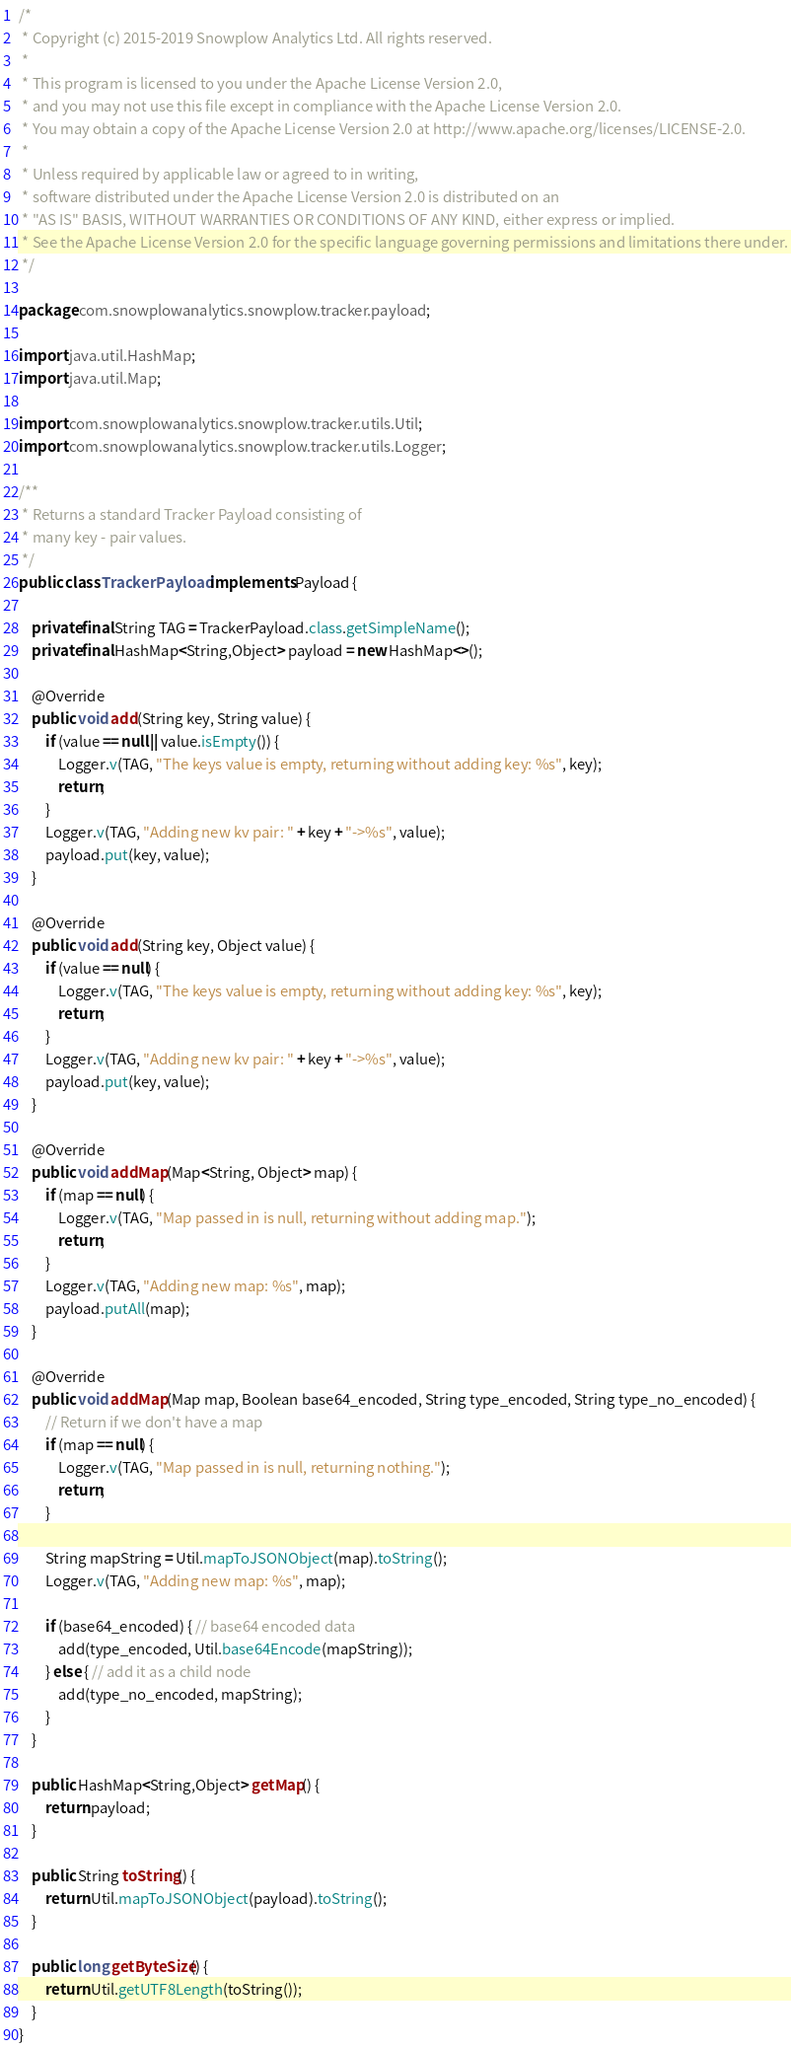<code> <loc_0><loc_0><loc_500><loc_500><_Java_>/*
 * Copyright (c) 2015-2019 Snowplow Analytics Ltd. All rights reserved.
 *
 * This program is licensed to you under the Apache License Version 2.0,
 * and you may not use this file except in compliance with the Apache License Version 2.0.
 * You may obtain a copy of the Apache License Version 2.0 at http://www.apache.org/licenses/LICENSE-2.0.
 *
 * Unless required by applicable law or agreed to in writing,
 * software distributed under the Apache License Version 2.0 is distributed on an
 * "AS IS" BASIS, WITHOUT WARRANTIES OR CONDITIONS OF ANY KIND, either express or implied.
 * See the Apache License Version 2.0 for the specific language governing permissions and limitations there under.
 */

package com.snowplowanalytics.snowplow.tracker.payload;

import java.util.HashMap;
import java.util.Map;

import com.snowplowanalytics.snowplow.tracker.utils.Util;
import com.snowplowanalytics.snowplow.tracker.utils.Logger;

/**
 * Returns a standard Tracker Payload consisting of
 * many key - pair values.
 */
public class TrackerPayload implements Payload {

    private final String TAG = TrackerPayload.class.getSimpleName();
    private final HashMap<String,Object> payload = new HashMap<>();
    
    @Override
    public void add(String key, String value) {
        if (value == null || value.isEmpty()) {
            Logger.v(TAG, "The keys value is empty, returning without adding key: %s", key);
            return;
        }
        Logger.v(TAG, "Adding new kv pair: " + key + "->%s", value);
        payload.put(key, value);
    }

    @Override
    public void add(String key, Object value) {
        if (value == null) {
            Logger.v(TAG, "The keys value is empty, returning without adding key: %s", key);
            return;
        }
        Logger.v(TAG, "Adding new kv pair: " + key + "->%s", value);
        payload.put(key, value);
    }

    @Override
    public void addMap(Map<String, Object> map) {
        if (map == null) {
            Logger.v(TAG, "Map passed in is null, returning without adding map.");
            return;
        }
        Logger.v(TAG, "Adding new map: %s", map);
        payload.putAll(map);
    }

    @Override
    public void addMap(Map map, Boolean base64_encoded, String type_encoded, String type_no_encoded) {
        // Return if we don't have a map
        if (map == null) {
            Logger.v(TAG, "Map passed in is null, returning nothing.");
            return;
        }

        String mapString = Util.mapToJSONObject(map).toString();
        Logger.v(TAG, "Adding new map: %s", map);

        if (base64_encoded) { // base64 encoded data
            add(type_encoded, Util.base64Encode(mapString));
        } else { // add it as a child node
            add(type_no_encoded, mapString);
        }
    }

    public HashMap<String,Object> getMap() {
        return payload;
    }

    public String toString() {
        return Util.mapToJSONObject(payload).toString();
    }

    public long getByteSize() {
        return Util.getUTF8Length(toString());
    }
}
</code> 